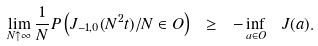Convert formula to latex. <formula><loc_0><loc_0><loc_500><loc_500>\lim _ { N \uparrow \infty } \frac { 1 } { N } P \left ( J _ { - 1 , 0 } ( N ^ { 2 } t ) / N \in O \right ) \ \geq \ - \inf _ { a \in O } \ J ( a ) .</formula> 